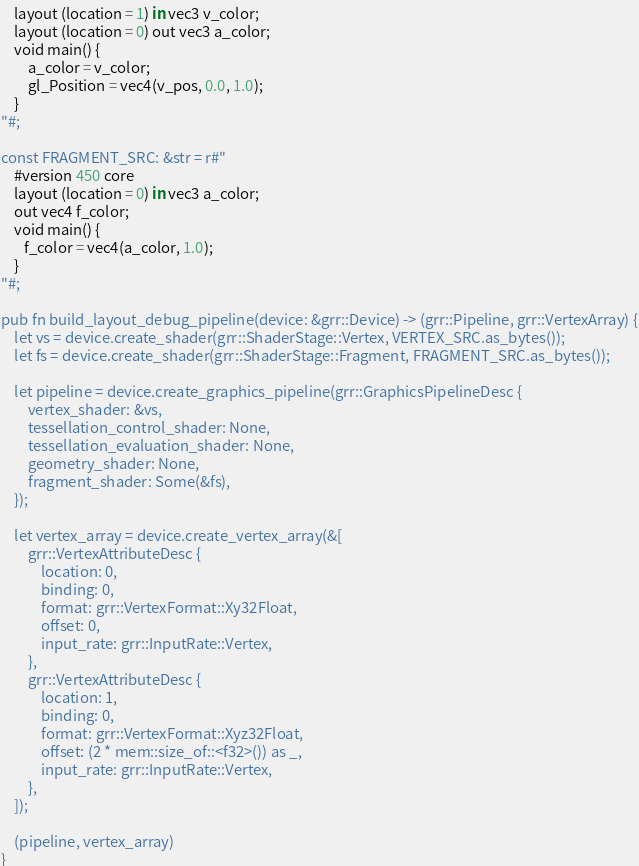Convert code to text. <code><loc_0><loc_0><loc_500><loc_500><_Rust_>    layout (location = 1) in vec3 v_color;
    layout (location = 0) out vec3 a_color;
    void main() {
        a_color = v_color;
        gl_Position = vec4(v_pos, 0.0, 1.0);
    }
"#;

const FRAGMENT_SRC: &str = r#"
    #version 450 core
    layout (location = 0) in vec3 a_color;
    out vec4 f_color;
    void main() {
       f_color = vec4(a_color, 1.0);
    }
"#;

pub fn build_layout_debug_pipeline(device: &grr::Device) -> (grr::Pipeline, grr::VertexArray) {
    let vs = device.create_shader(grr::ShaderStage::Vertex, VERTEX_SRC.as_bytes());
    let fs = device.create_shader(grr::ShaderStage::Fragment, FRAGMENT_SRC.as_bytes());

    let pipeline = device.create_graphics_pipeline(grr::GraphicsPipelineDesc {
        vertex_shader: &vs,
        tessellation_control_shader: None,
        tessellation_evaluation_shader: None,
        geometry_shader: None,
        fragment_shader: Some(&fs),
    });

    let vertex_array = device.create_vertex_array(&[
        grr::VertexAttributeDesc {
            location: 0,
            binding: 0,
            format: grr::VertexFormat::Xy32Float,
            offset: 0,
            input_rate: grr::InputRate::Vertex,
        },
        grr::VertexAttributeDesc {
            location: 1,
            binding: 0,
            format: grr::VertexFormat::Xyz32Float,
            offset: (2 * mem::size_of::<f32>()) as _,
            input_rate: grr::InputRate::Vertex,
        },
    ]);

    (pipeline, vertex_array)
}
</code> 